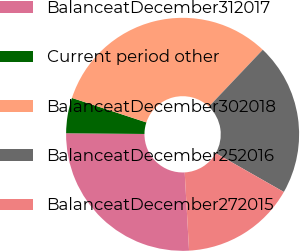Convert chart to OTSL. <chart><loc_0><loc_0><loc_500><loc_500><pie_chart><fcel>BalanceatDecember312017<fcel>Current period other<fcel>BalanceatDecember302018<fcel>BalanceatDecember252016<fcel>BalanceatDecember272015<nl><fcel>26.03%<fcel>4.91%<fcel>32.02%<fcel>21.16%<fcel>15.88%<nl></chart> 